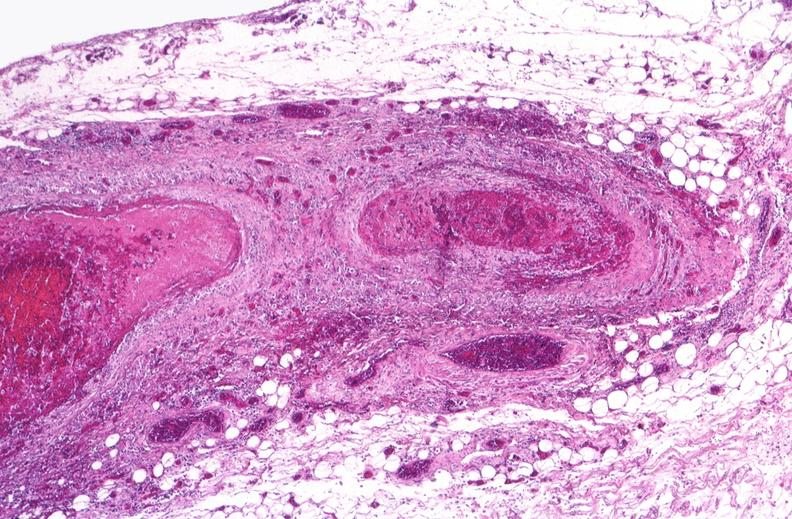does nodular tumor show polyarteritis nodosa?
Answer the question using a single word or phrase. No 